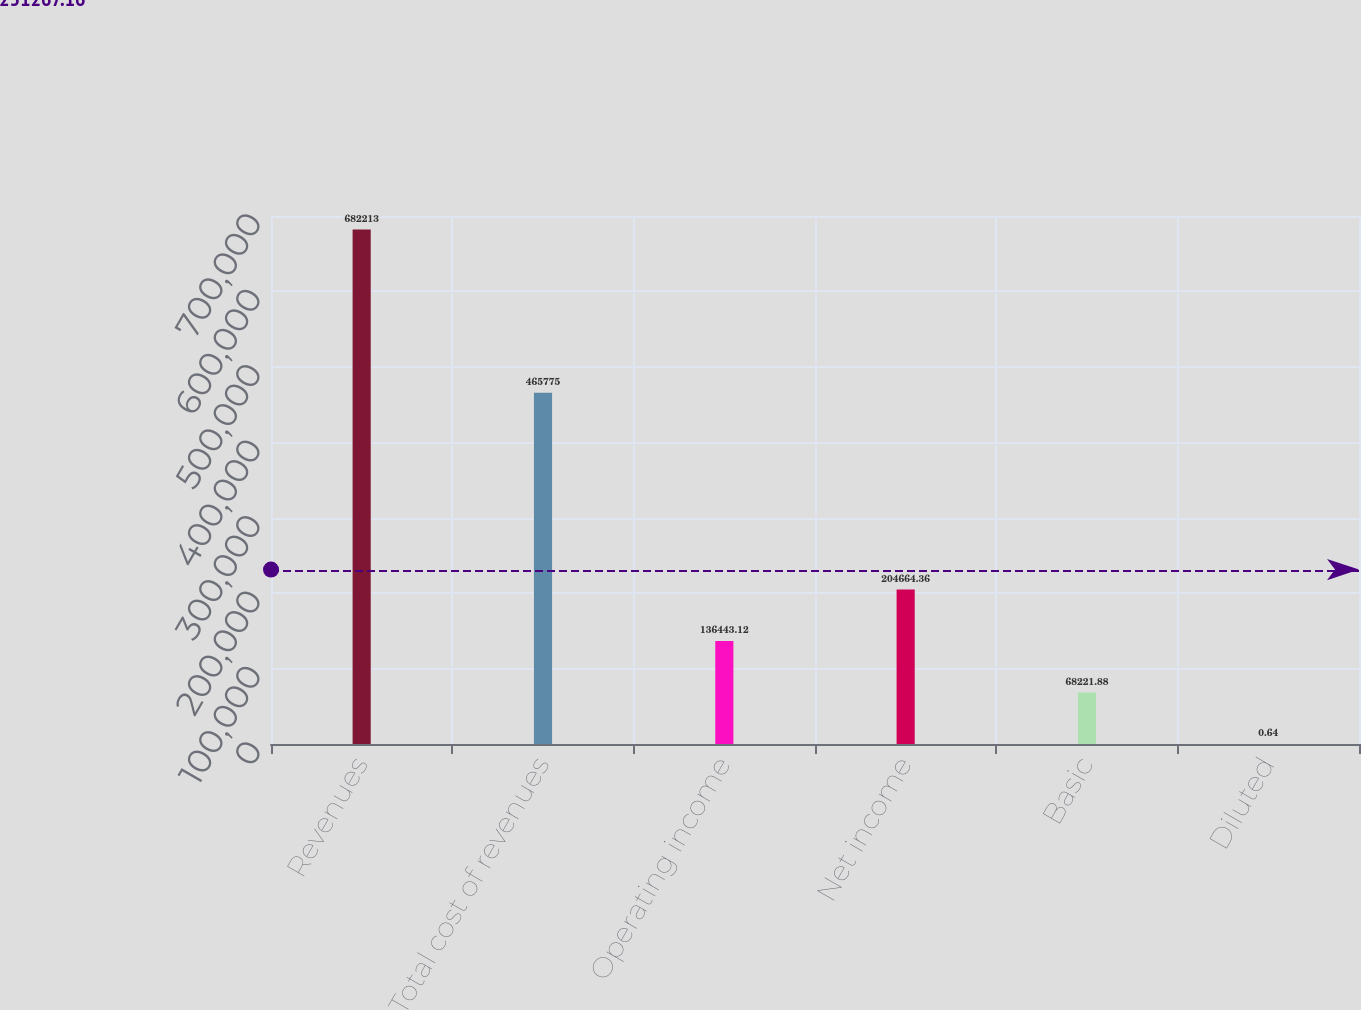Convert chart. <chart><loc_0><loc_0><loc_500><loc_500><bar_chart><fcel>Revenues<fcel>Total cost of revenues<fcel>Operating income<fcel>Net income<fcel>Basic<fcel>Diluted<nl><fcel>682213<fcel>465775<fcel>136443<fcel>204664<fcel>68221.9<fcel>0.64<nl></chart> 